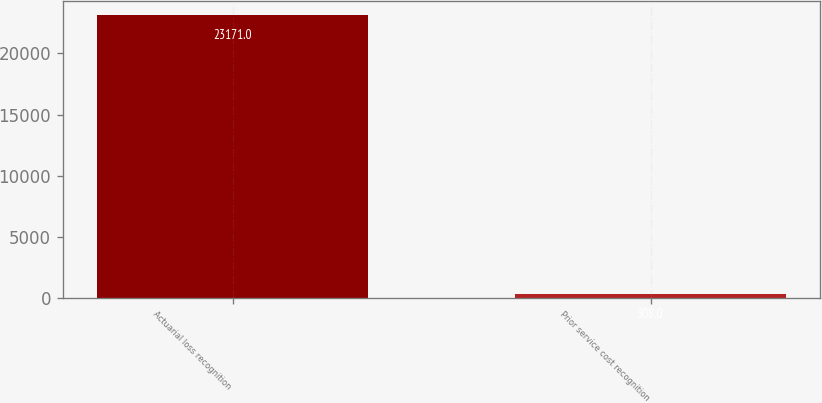<chart> <loc_0><loc_0><loc_500><loc_500><bar_chart><fcel>Actuarial loss recognition<fcel>Prior service cost recognition<nl><fcel>23171<fcel>308<nl></chart> 